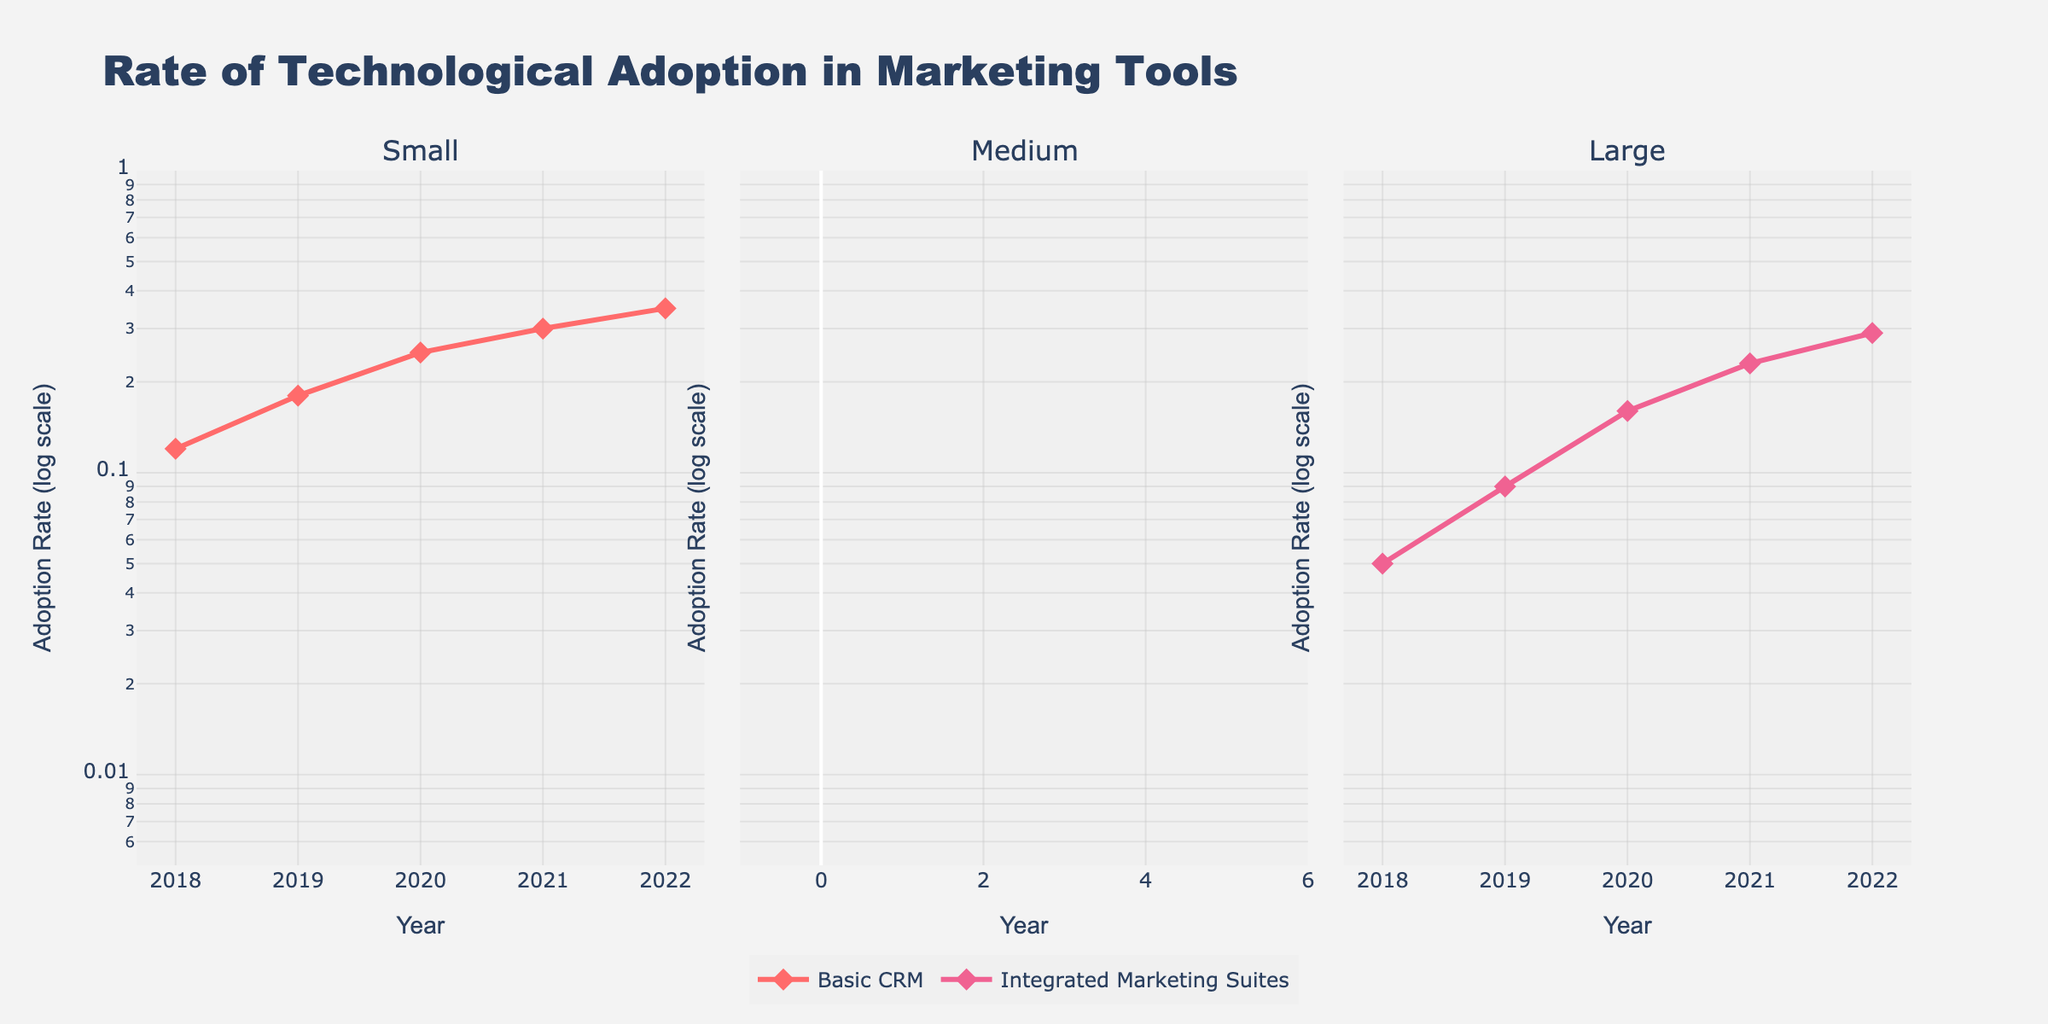What is the title of the plot? The title of the plot is usually positioned at the top and is in larger font size compared to other text elements. Here, the title reads "Rate of Technological Adoption in Marketing Tools".
Answer: Rate of Technological Adoption in Marketing Tools Which business size shows the highest adoption rate for AI-Powered Marketing Automation in 2022? To find this, look at the subplot for the business size that included AI-Powered Marketing Automation, which is for Large businesses. Check the line representing AI-Powered Marketing Automation in 2022.
Answer: Large What is the adoption rate for Social Media Management Tools among small businesses in 2020? Navigate to the subplot for small businesses, and locate the line for Social Media Management Tools. The data point for the year 2020 indicates the adoption rate.
Answer: 0.33 By how much did the adoption rate of Advanced Analytics for medium businesses increase from 2018 to 2022? In the medium business subplot, identify the data points for Advanced Analytics in 2018 and 2022. Subtract the 2018 adoption rate from the 2022 adoption rate (0.33 - 0.08).
Answer: 0.25 Compare the adoption rates of Marketing Analytics Platforms for medium businesses and Integrated Marketing Suites for large businesses in 2019. Which one had a higher adoption rate? Identify the 2019 data points for Marketing Analytics Platforms in the medium business subplot and for Integrated Marketing Suites in the large business subplot. Compare the two rates: 0.18 (medium) and 0.09 (large).
Answer: Medium businesses What is the general trend for the adoption rate of Basic CRM among small businesses from 2018 to 2022? Looking at the small businesses subplot and the line for Basic CRM, observe the pattern of the data points from 2018 to 2022. The trend indicates a continuous increase.
Answer: Increasing Calculate the average adoption rate of Integrated Marketing Suites for large businesses over the years 2018 to 2022. Find the adoption rate values for Integrated Marketing Suites in the large business subplot for each year, sum them up, and divide by the number of years (0.05 + 0.09 + 0.16 + 0.23 + 0.29 = 0.82; 0.82 / 5).
Answer: 0.164 Which tool among medium businesses had a higher adoption rate in 2020: Advanced Analytics or Marketing Analytics Platforms? Locate the 2020 data points for both Advanced Analytics and Marketing Analytics Platforms within the medium business subplot. Compare the two values: 0.20 for Advanced Analytics and 0.27 for Marketing Analytics Platforms.
Answer: Marketing Analytics Platforms What are the y-axis labels for the subplots, and what type of scale is used? Examine the y-axis of any subplot. The label reads "Adoption Rate (log scale)," indicating that a logarithmic scale is used.
Answer: Adoption Rate (log scale) How many years of data are shown for each tool? The x-axis for all the subplots reveals years from 2018 to 2022. Counting these gives the number of years.
Answer: 5 